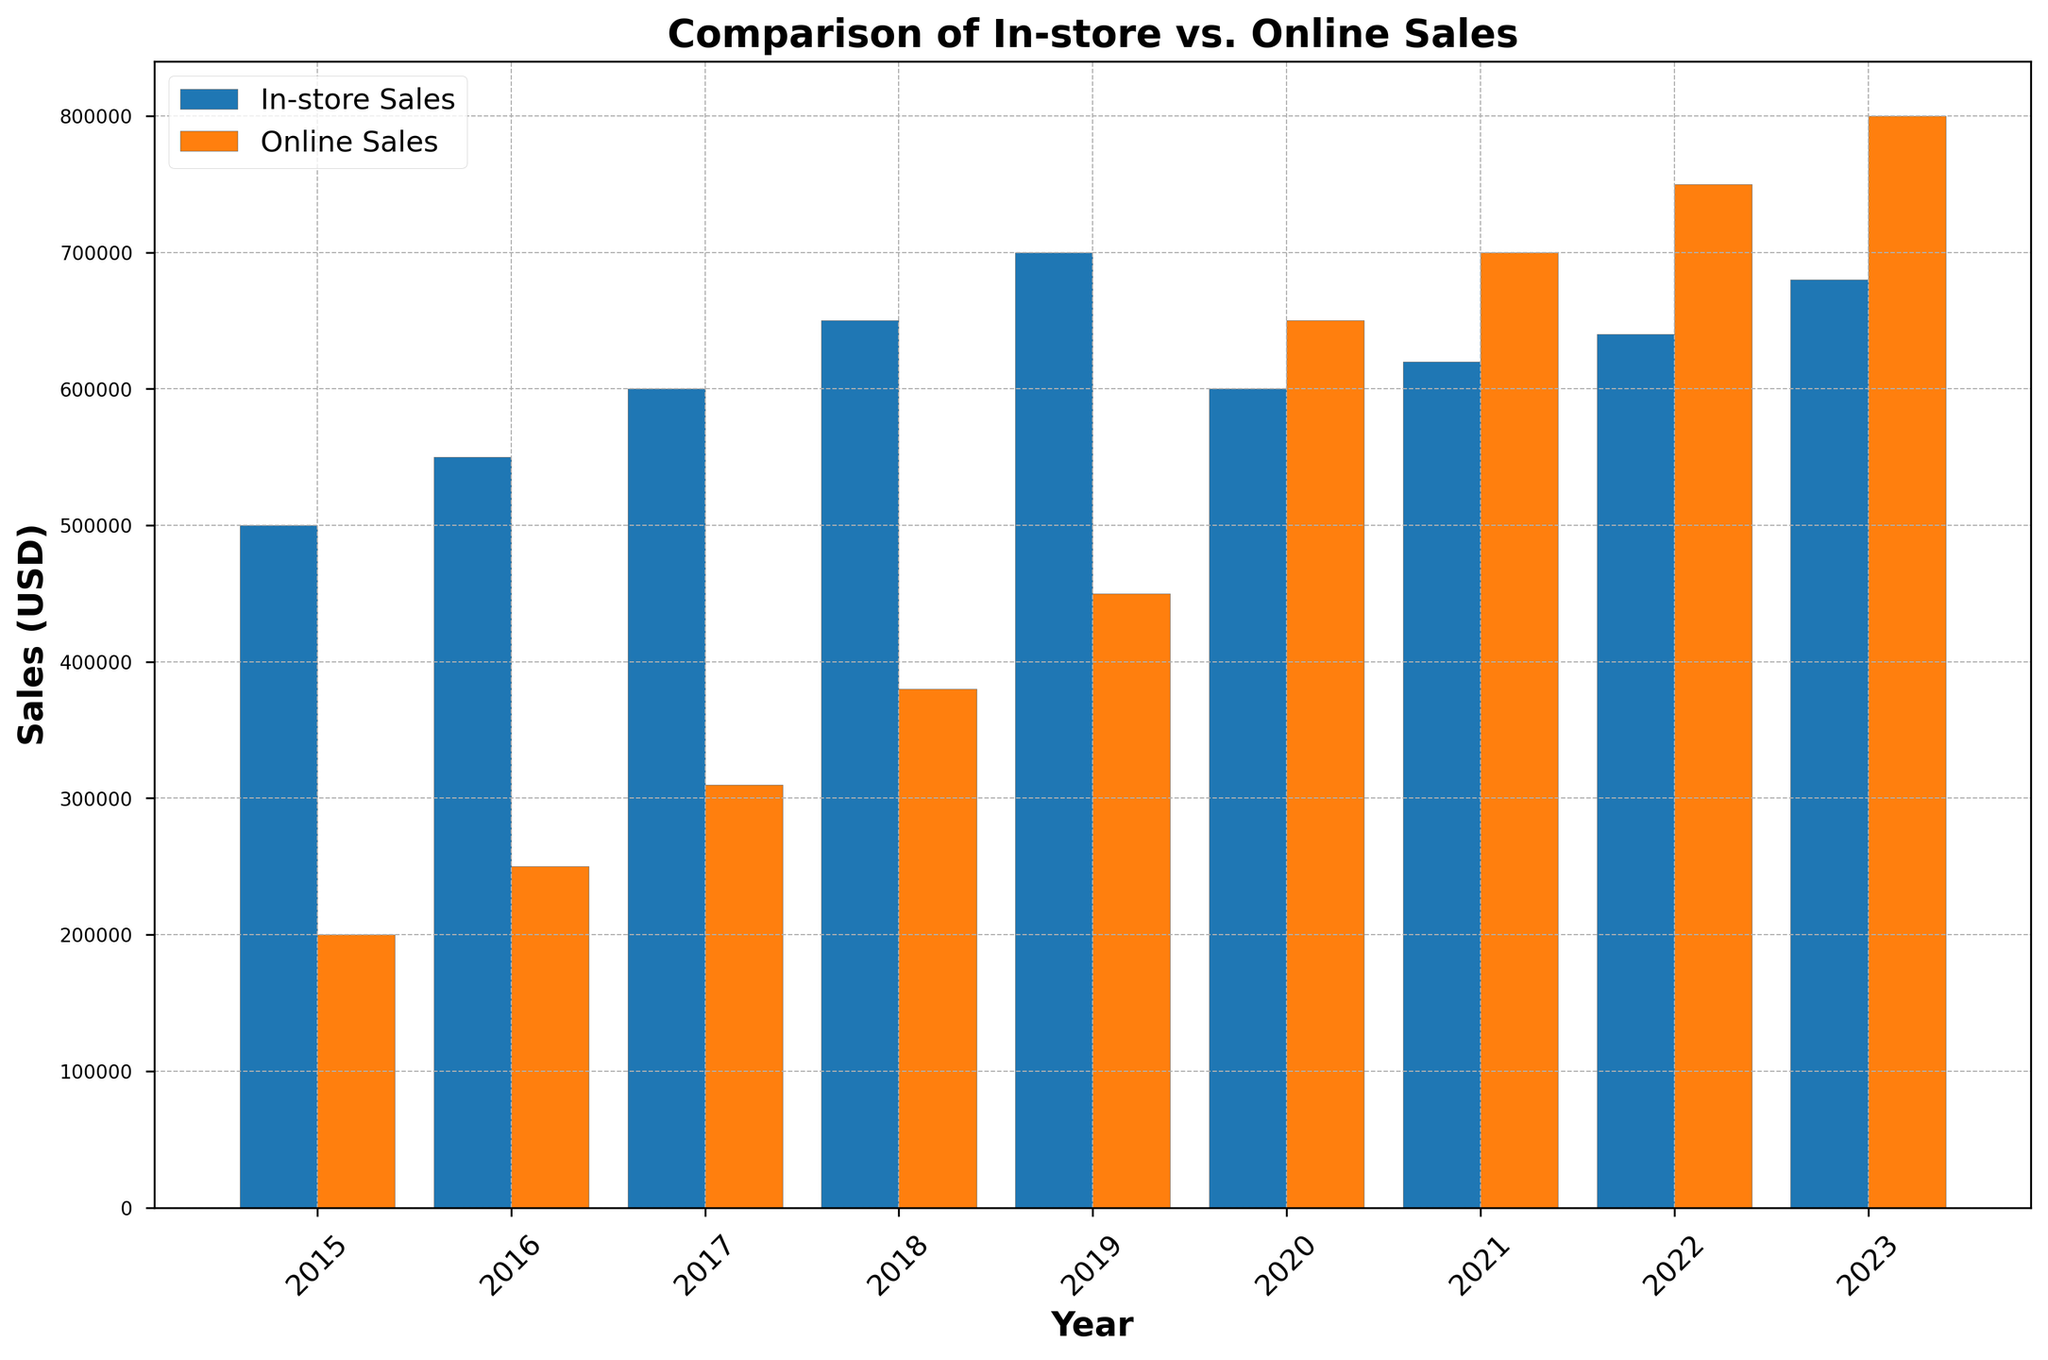What was the difference between In-store Sales and Online Sales in 2020? The In-store Sales in 2020 were 600,000 USD, while the Online Sales were 650,000 USD. The difference is 650,000 - 600,000.
Answer: 50,000 USD Between which years did In-store Sales see the highest growth? In-store Sales grew by the largest amount from 2018 to 2019, increasing from 650,000 USD to 700,000 USD, which is an increase of 50,000 USD.
Answer: 2018 to 2019 How did the relationship between In-store Sales and Online Sales change from 2019 to 2020? In 2019, In-store Sales were higher at 700,000 USD compared to Online Sales at 450,000 USD. In 2020, Online Sales surpassed In-store Sales, with Online Sales at 650,000 USD and In-store Sales at 600,000 USD.
Answer: Online Sales surpassed In-store Sales What were the total sales (In-store + Online) for the year 2023? The In-store Sales for 2023 were 680,000 USD and the Online Sales were 800,000 USD. Adding them together gives 680,000 + 800,000.
Answer: 1,480,000 USD Identify the year when Online Sales first exceeded In-store Sales. By examining the vertical bars of Online Sales and In-store Sales, Online Sales first exceeded In-store Sales in the year 2020.
Answer: 2020 What trend can be observed in Online Sales from 2015 to 2023? From observing the height of the orange bars representing Online Sales, it's evident that there is a continuous upward trend each year, showing consistent growth.
Answer: Continuous upward trend If the trend continues, what could be a reasonable estimate for Online Sales in 2024? The Online Sales increased by around 50,000 USD each year from 2020 to 2023. A reasonable estimate for Online Sales in 2024 would be around 800,000 + 50,000.
Answer: 850,000 USD Which year had the smallest gap between In-store Sales and Online Sales? The smallest gap occurs in 2023 where In-store Sales were 680,000 USD and Online Sales were 800,000 USD, giving a difference of 120,000 USD.
Answer: 2023 How did Online Sales change between 2018 and 2021? Online Sales were 380,000 USD in 2018 and increased to 700,000 USD in 2021. The total change is 700,000 - 380,000.
Answer: 320,000 USD 